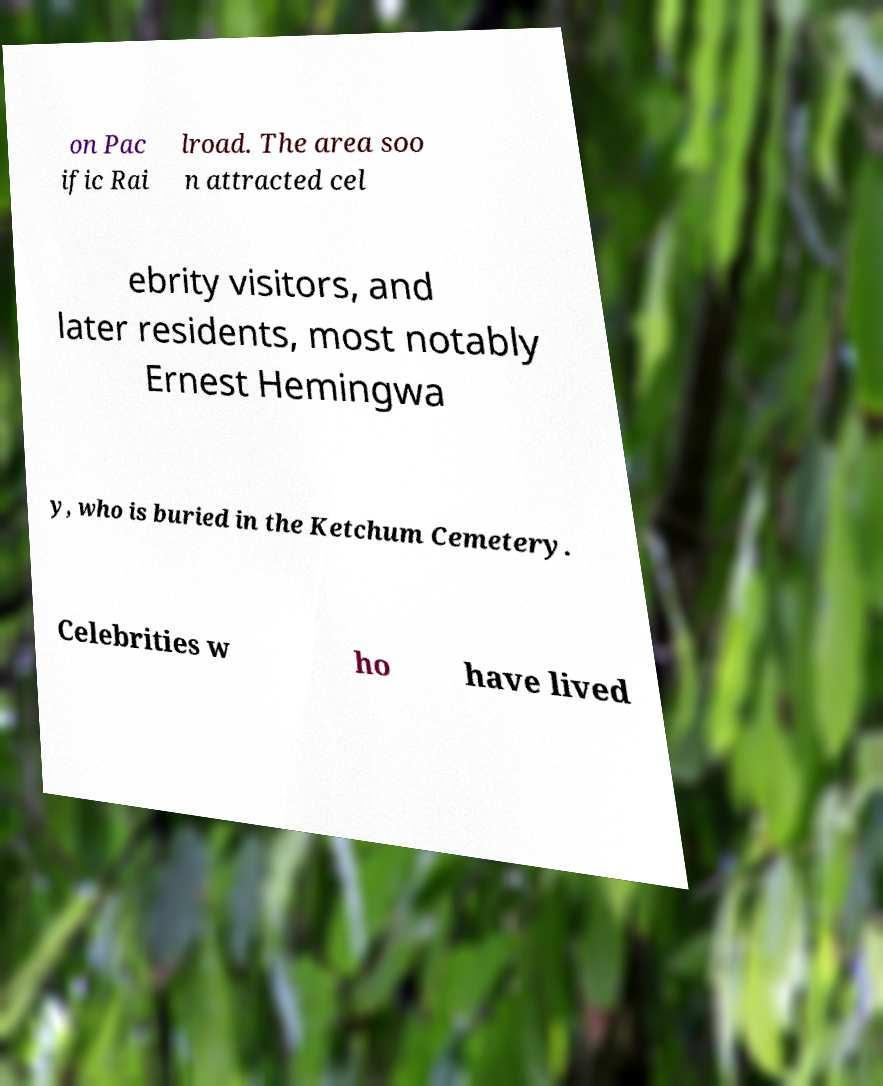Could you assist in decoding the text presented in this image and type it out clearly? on Pac ific Rai lroad. The area soo n attracted cel ebrity visitors, and later residents, most notably Ernest Hemingwa y, who is buried in the Ketchum Cemetery. Celebrities w ho have lived 